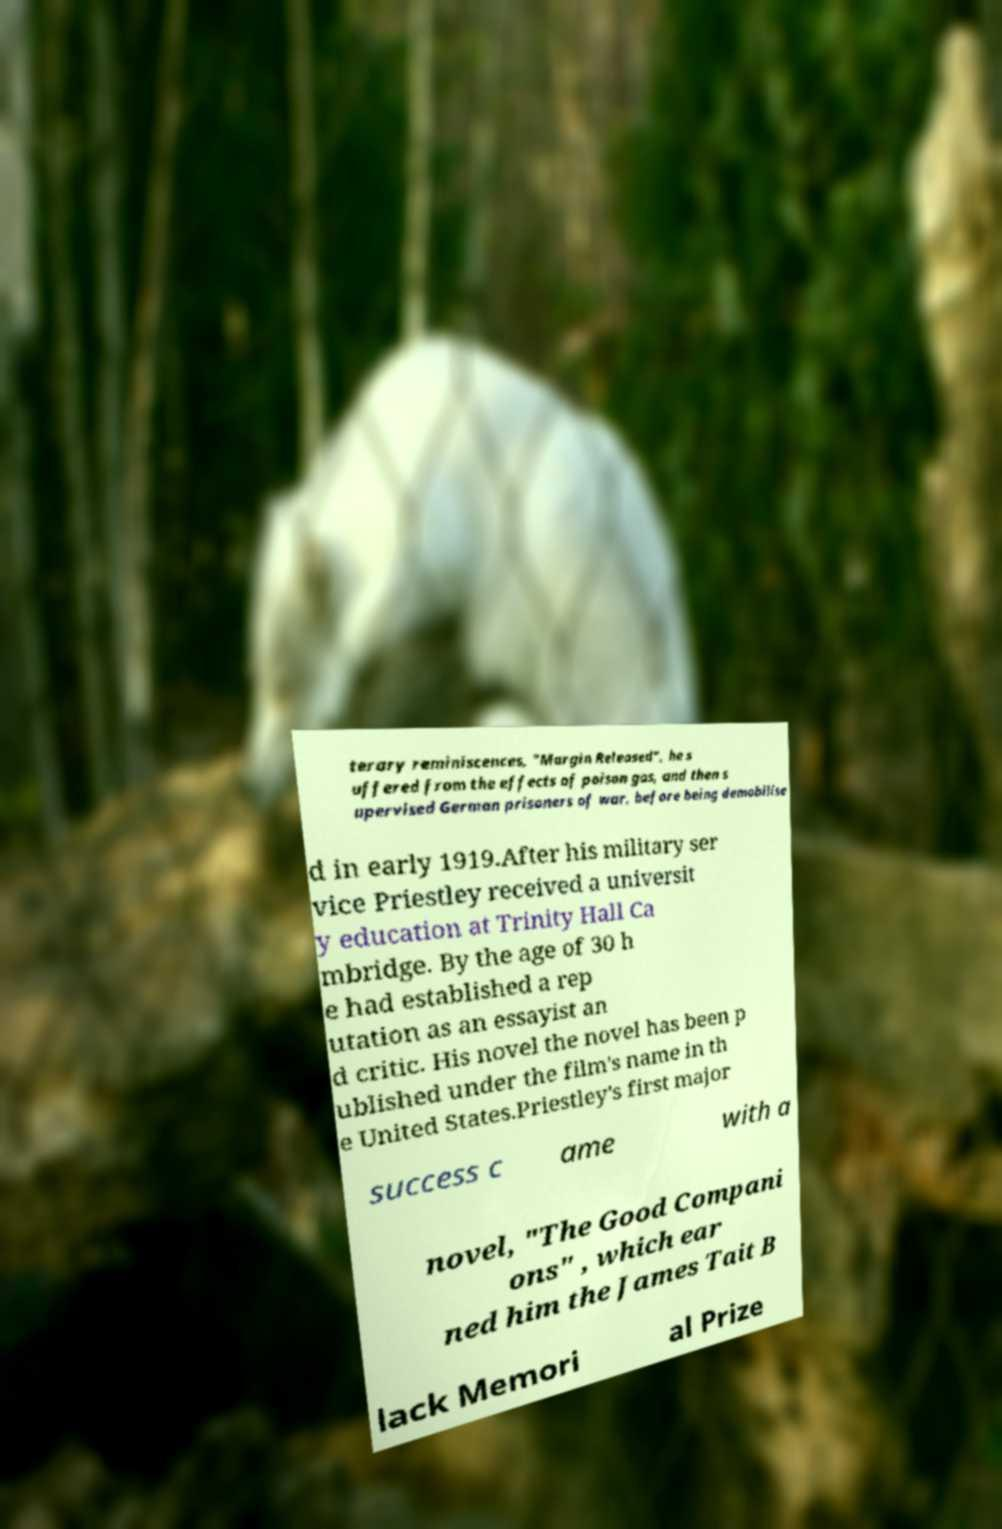What messages or text are displayed in this image? I need them in a readable, typed format. terary reminiscences, "Margin Released", he s uffered from the effects of poison gas, and then s upervised German prisoners of war, before being demobilise d in early 1919.After his military ser vice Priestley received a universit y education at Trinity Hall Ca mbridge. By the age of 30 h e had established a rep utation as an essayist an d critic. His novel the novel has been p ublished under the film's name in th e United States.Priestley's first major success c ame with a novel, "The Good Compani ons" , which ear ned him the James Tait B lack Memori al Prize 